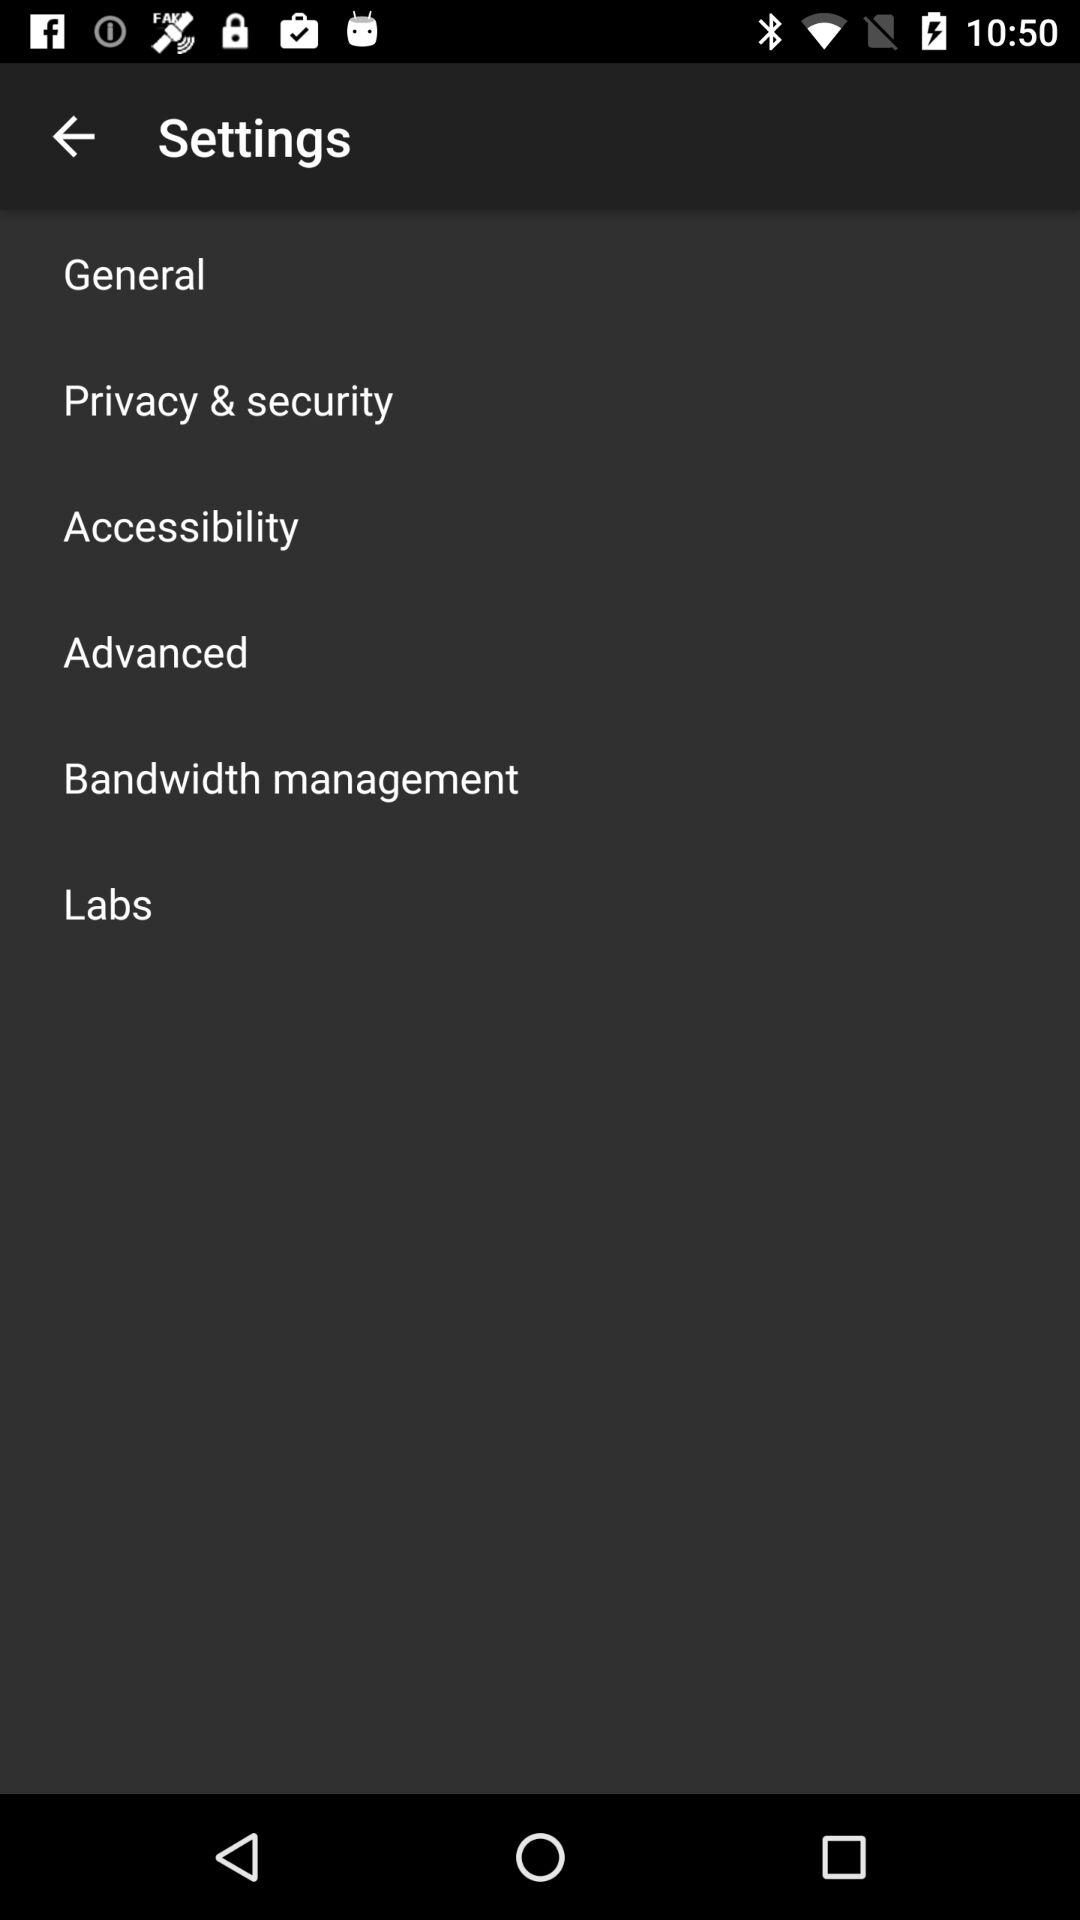How many items are there in the settings menu?
Answer the question using a single word or phrase. 6 